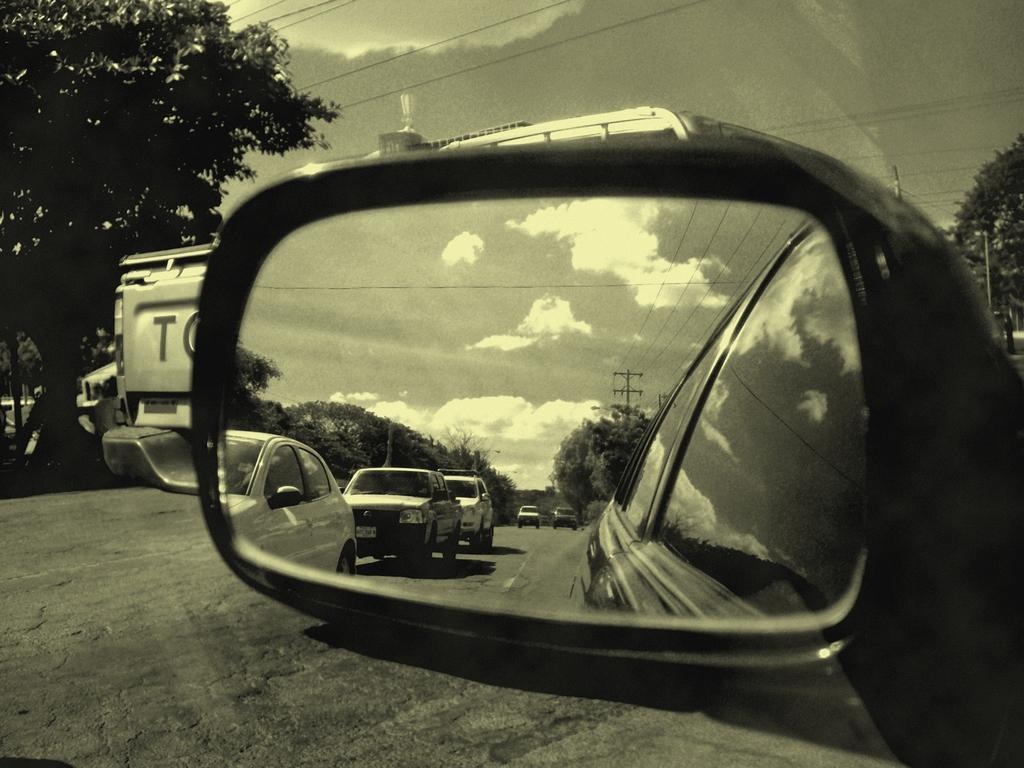How would you summarize this image in a sentence or two? This is a black and white image and here we can see a mirror of a vehicle and through the glass we can see some vehicles on the road and there are trees, poles along with wires. At the top, there is sky. 